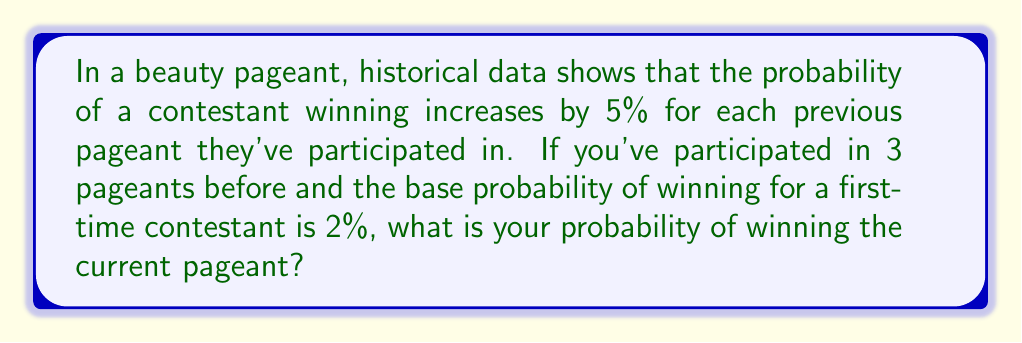Show me your answer to this math problem. Let's approach this step-by-step:

1) The base probability for a first-time contestant is 2% or 0.02.

2) Each previous pageant increases the probability by 5% or 0.05.

3) You've participated in 3 pageants before, so we need to add 3 times the increase:

   $$ P = 0.02 + (3 \times 0.05) $$

4) Let's calculate:

   $$ P = 0.02 + 0.15 = 0.17 $$

5) Convert to percentage:

   $$ P = 0.17 \times 100\% = 17\% $$

Therefore, your probability of winning the current pageant is 17%.
Answer: 17% 